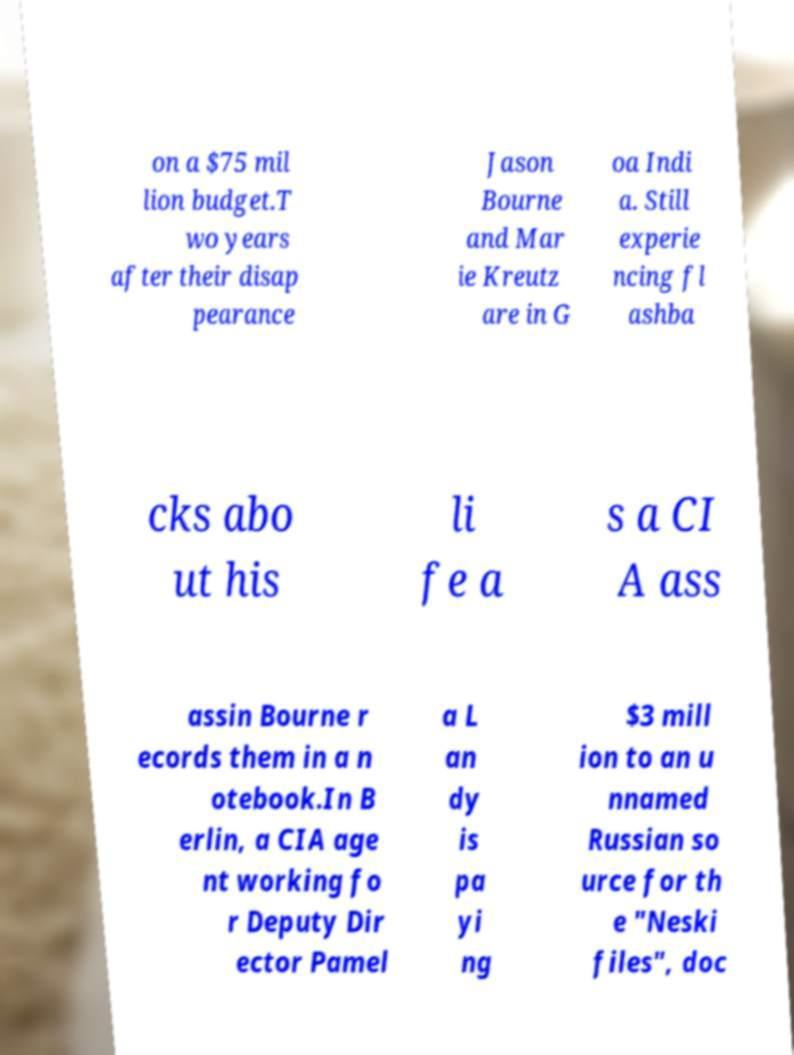Please identify and transcribe the text found in this image. on a $75 mil lion budget.T wo years after their disap pearance Jason Bourne and Mar ie Kreutz are in G oa Indi a. Still experie ncing fl ashba cks abo ut his li fe a s a CI A ass assin Bourne r ecords them in a n otebook.In B erlin, a CIA age nt working fo r Deputy Dir ector Pamel a L an dy is pa yi ng $3 mill ion to an u nnamed Russian so urce for th e "Neski files", doc 